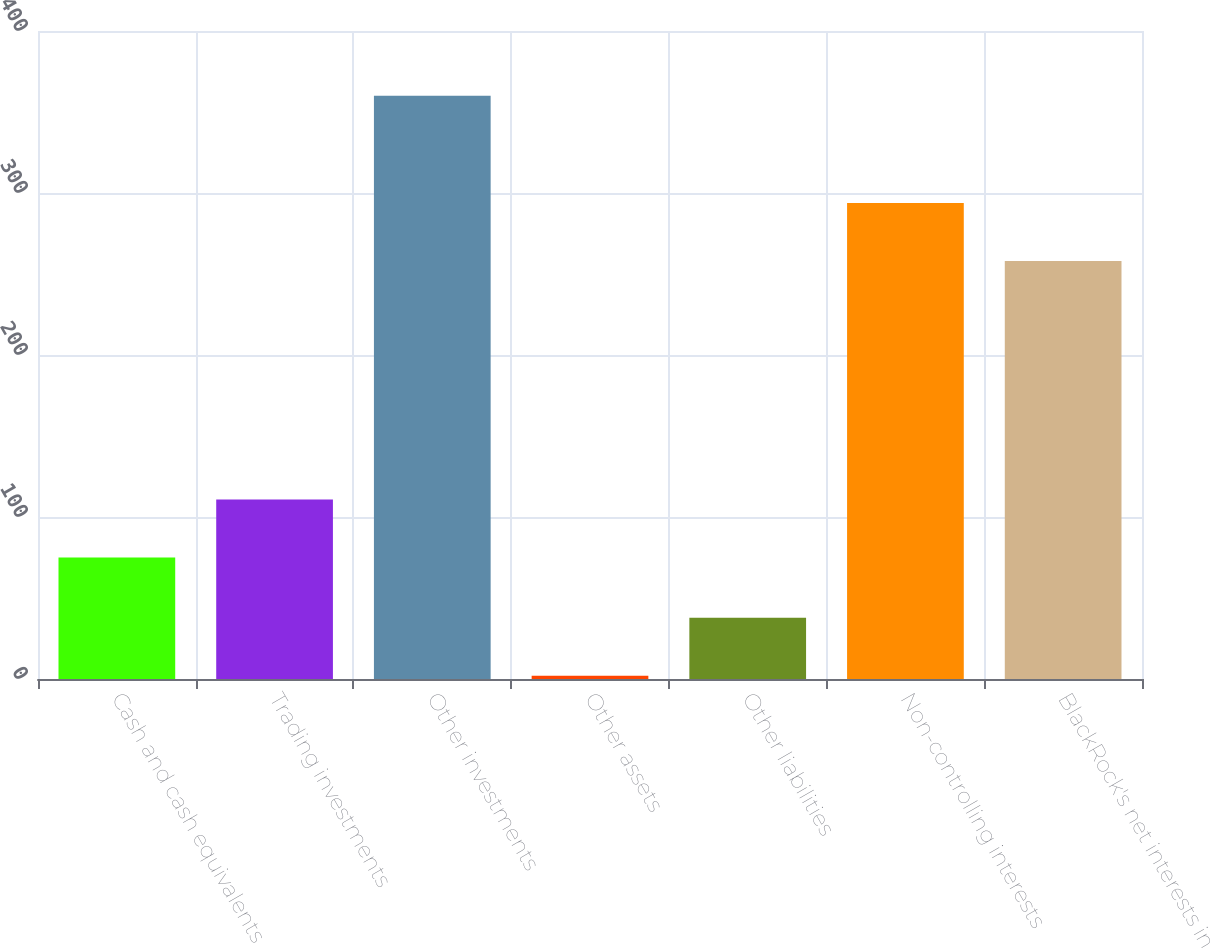Convert chart to OTSL. <chart><loc_0><loc_0><loc_500><loc_500><bar_chart><fcel>Cash and cash equivalents<fcel>Trading investments<fcel>Other investments<fcel>Other assets<fcel>Other liabilities<fcel>Non-controlling interests<fcel>BlackRock's net interests in<nl><fcel>75<fcel>110.8<fcel>360<fcel>2<fcel>37.8<fcel>293.8<fcel>258<nl></chart> 